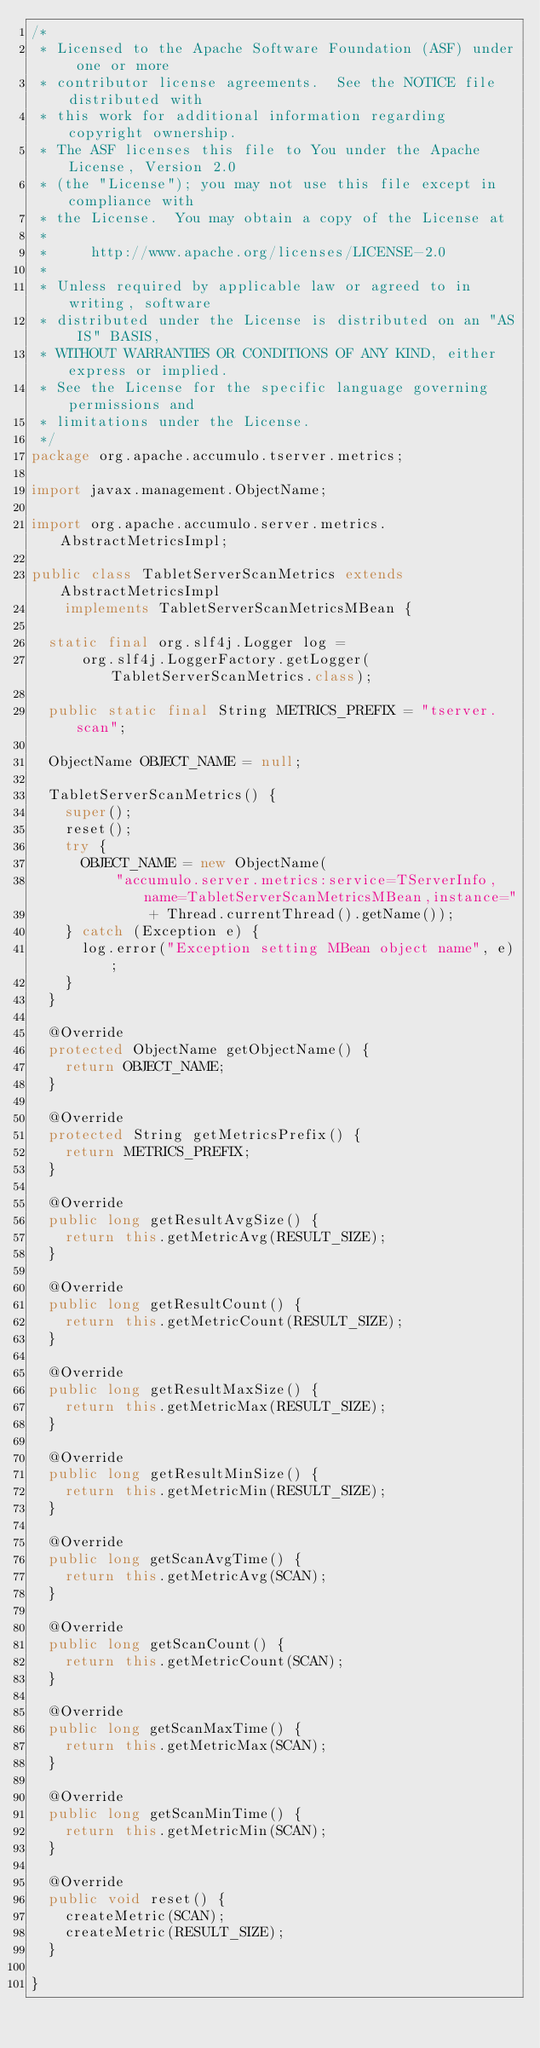Convert code to text. <code><loc_0><loc_0><loc_500><loc_500><_Java_>/*
 * Licensed to the Apache Software Foundation (ASF) under one or more
 * contributor license agreements.  See the NOTICE file distributed with
 * this work for additional information regarding copyright ownership.
 * The ASF licenses this file to You under the Apache License, Version 2.0
 * (the "License"); you may not use this file except in compliance with
 * the License.  You may obtain a copy of the License at
 *
 *     http://www.apache.org/licenses/LICENSE-2.0
 *
 * Unless required by applicable law or agreed to in writing, software
 * distributed under the License is distributed on an "AS IS" BASIS,
 * WITHOUT WARRANTIES OR CONDITIONS OF ANY KIND, either express or implied.
 * See the License for the specific language governing permissions and
 * limitations under the License.
 */
package org.apache.accumulo.tserver.metrics;

import javax.management.ObjectName;

import org.apache.accumulo.server.metrics.AbstractMetricsImpl;

public class TabletServerScanMetrics extends AbstractMetricsImpl
    implements TabletServerScanMetricsMBean {

  static final org.slf4j.Logger log =
      org.slf4j.LoggerFactory.getLogger(TabletServerScanMetrics.class);

  public static final String METRICS_PREFIX = "tserver.scan";

  ObjectName OBJECT_NAME = null;

  TabletServerScanMetrics() {
    super();
    reset();
    try {
      OBJECT_NAME = new ObjectName(
          "accumulo.server.metrics:service=TServerInfo,name=TabletServerScanMetricsMBean,instance="
              + Thread.currentThread().getName());
    } catch (Exception e) {
      log.error("Exception setting MBean object name", e);
    }
  }

  @Override
  protected ObjectName getObjectName() {
    return OBJECT_NAME;
  }

  @Override
  protected String getMetricsPrefix() {
    return METRICS_PREFIX;
  }

  @Override
  public long getResultAvgSize() {
    return this.getMetricAvg(RESULT_SIZE);
  }

  @Override
  public long getResultCount() {
    return this.getMetricCount(RESULT_SIZE);
  }

  @Override
  public long getResultMaxSize() {
    return this.getMetricMax(RESULT_SIZE);
  }

  @Override
  public long getResultMinSize() {
    return this.getMetricMin(RESULT_SIZE);
  }

  @Override
  public long getScanAvgTime() {
    return this.getMetricAvg(SCAN);
  }

  @Override
  public long getScanCount() {
    return this.getMetricCount(SCAN);
  }

  @Override
  public long getScanMaxTime() {
    return this.getMetricMax(SCAN);
  }

  @Override
  public long getScanMinTime() {
    return this.getMetricMin(SCAN);
  }

  @Override
  public void reset() {
    createMetric(SCAN);
    createMetric(RESULT_SIZE);
  }

}
</code> 